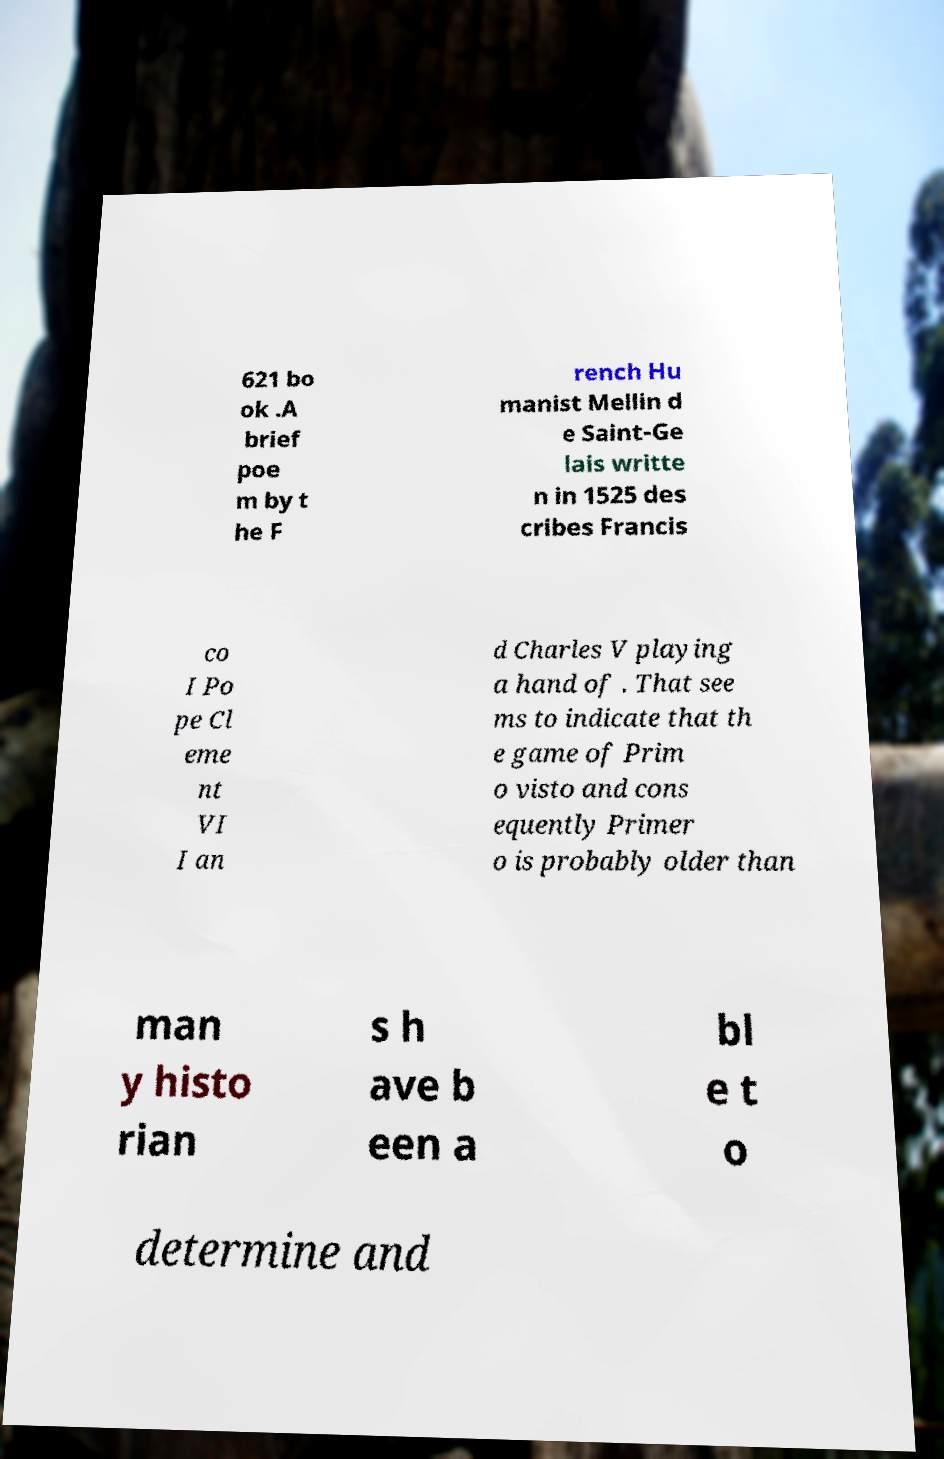Please read and relay the text visible in this image. What does it say? 621 bo ok .A brief poe m by t he F rench Hu manist Mellin d e Saint-Ge lais writte n in 1525 des cribes Francis co I Po pe Cl eme nt VI I an d Charles V playing a hand of . That see ms to indicate that th e game of Prim o visto and cons equently Primer o is probably older than man y histo rian s h ave b een a bl e t o determine and 